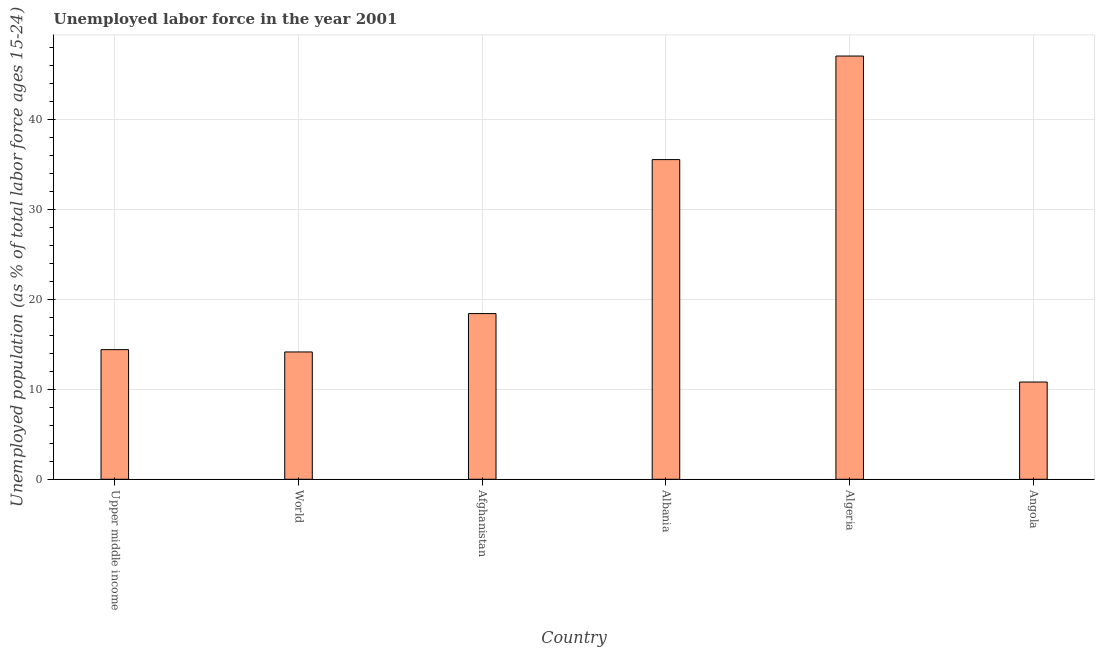Does the graph contain any zero values?
Your answer should be very brief. No. What is the title of the graph?
Give a very brief answer. Unemployed labor force in the year 2001. What is the label or title of the Y-axis?
Give a very brief answer. Unemployed population (as % of total labor force ages 15-24). What is the total unemployed youth population in World?
Ensure brevity in your answer.  14.14. Across all countries, what is the minimum total unemployed youth population?
Provide a succinct answer. 10.8. In which country was the total unemployed youth population maximum?
Give a very brief answer. Algeria. In which country was the total unemployed youth population minimum?
Your response must be concise. Angola. What is the sum of the total unemployed youth population?
Make the answer very short. 140.23. What is the difference between the total unemployed youth population in Afghanistan and World?
Offer a very short reply. 4.26. What is the average total unemployed youth population per country?
Your response must be concise. 23.37. What is the median total unemployed youth population?
Your answer should be very brief. 16.4. What is the ratio of the total unemployed youth population in Algeria to that in World?
Your response must be concise. 3.32. Is the difference between the total unemployed youth population in Algeria and Angola greater than the difference between any two countries?
Offer a terse response. Yes. What is the difference between the highest and the lowest total unemployed youth population?
Your response must be concise. 36.2. How many bars are there?
Offer a very short reply. 6. Are all the bars in the graph horizontal?
Provide a short and direct response. No. What is the Unemployed population (as % of total labor force ages 15-24) in Upper middle income?
Provide a succinct answer. 14.4. What is the Unemployed population (as % of total labor force ages 15-24) in World?
Provide a short and direct response. 14.14. What is the Unemployed population (as % of total labor force ages 15-24) of Afghanistan?
Offer a very short reply. 18.4. What is the Unemployed population (as % of total labor force ages 15-24) of Albania?
Ensure brevity in your answer.  35.5. What is the Unemployed population (as % of total labor force ages 15-24) of Angola?
Offer a very short reply. 10.8. What is the difference between the Unemployed population (as % of total labor force ages 15-24) in Upper middle income and World?
Your answer should be very brief. 0.26. What is the difference between the Unemployed population (as % of total labor force ages 15-24) in Upper middle income and Afghanistan?
Make the answer very short. -4. What is the difference between the Unemployed population (as % of total labor force ages 15-24) in Upper middle income and Albania?
Provide a succinct answer. -21.1. What is the difference between the Unemployed population (as % of total labor force ages 15-24) in Upper middle income and Algeria?
Keep it short and to the point. -32.6. What is the difference between the Unemployed population (as % of total labor force ages 15-24) in Upper middle income and Angola?
Provide a short and direct response. 3.6. What is the difference between the Unemployed population (as % of total labor force ages 15-24) in World and Afghanistan?
Offer a terse response. -4.26. What is the difference between the Unemployed population (as % of total labor force ages 15-24) in World and Albania?
Offer a very short reply. -21.36. What is the difference between the Unemployed population (as % of total labor force ages 15-24) in World and Algeria?
Offer a terse response. -32.86. What is the difference between the Unemployed population (as % of total labor force ages 15-24) in World and Angola?
Provide a succinct answer. 3.34. What is the difference between the Unemployed population (as % of total labor force ages 15-24) in Afghanistan and Albania?
Provide a succinct answer. -17.1. What is the difference between the Unemployed population (as % of total labor force ages 15-24) in Afghanistan and Algeria?
Ensure brevity in your answer.  -28.6. What is the difference between the Unemployed population (as % of total labor force ages 15-24) in Albania and Angola?
Offer a very short reply. 24.7. What is the difference between the Unemployed population (as % of total labor force ages 15-24) in Algeria and Angola?
Make the answer very short. 36.2. What is the ratio of the Unemployed population (as % of total labor force ages 15-24) in Upper middle income to that in Afghanistan?
Your answer should be very brief. 0.78. What is the ratio of the Unemployed population (as % of total labor force ages 15-24) in Upper middle income to that in Albania?
Your answer should be very brief. 0.41. What is the ratio of the Unemployed population (as % of total labor force ages 15-24) in Upper middle income to that in Algeria?
Keep it short and to the point. 0.31. What is the ratio of the Unemployed population (as % of total labor force ages 15-24) in Upper middle income to that in Angola?
Provide a succinct answer. 1.33. What is the ratio of the Unemployed population (as % of total labor force ages 15-24) in World to that in Afghanistan?
Provide a short and direct response. 0.77. What is the ratio of the Unemployed population (as % of total labor force ages 15-24) in World to that in Albania?
Your answer should be compact. 0.4. What is the ratio of the Unemployed population (as % of total labor force ages 15-24) in World to that in Algeria?
Your answer should be very brief. 0.3. What is the ratio of the Unemployed population (as % of total labor force ages 15-24) in World to that in Angola?
Your answer should be very brief. 1.31. What is the ratio of the Unemployed population (as % of total labor force ages 15-24) in Afghanistan to that in Albania?
Offer a terse response. 0.52. What is the ratio of the Unemployed population (as % of total labor force ages 15-24) in Afghanistan to that in Algeria?
Provide a succinct answer. 0.39. What is the ratio of the Unemployed population (as % of total labor force ages 15-24) in Afghanistan to that in Angola?
Keep it short and to the point. 1.7. What is the ratio of the Unemployed population (as % of total labor force ages 15-24) in Albania to that in Algeria?
Your answer should be very brief. 0.76. What is the ratio of the Unemployed population (as % of total labor force ages 15-24) in Albania to that in Angola?
Offer a terse response. 3.29. What is the ratio of the Unemployed population (as % of total labor force ages 15-24) in Algeria to that in Angola?
Your answer should be very brief. 4.35. 